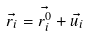Convert formula to latex. <formula><loc_0><loc_0><loc_500><loc_500>\vec { r _ { i } } = \vec { r _ { i } ^ { 0 } } + \vec { u _ { i } }</formula> 